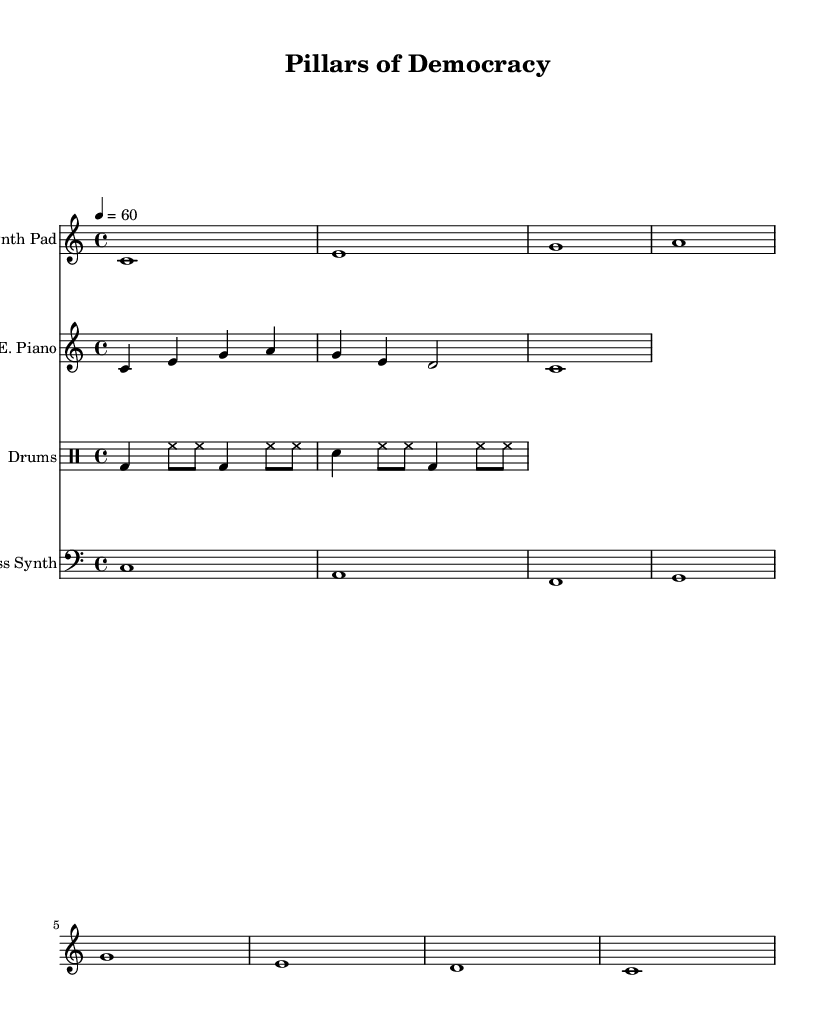What is the key signature of this music? The key signature is indicated at the beginning of the score and is C major, as there are no sharps or flats.
Answer: C major What is the time signature of the piece? The time signature is seen at the start of the score indicating the number of beats in each measure, which is 4/4.
Answer: 4/4 What is the tempo marking of this composition? The tempo marking is indicated in beats per minute, shown as 4 = 60, meaning there are 60 beats per minute.
Answer: 60 How many measures does the synth pad part contain? By examining the synth pad notation within the score, there are 8 distinct notes, which typically corresponds to 8 measures in this context.
Answer: 8 How many different instruments are featured in this score? The score displays four distinct staffs, indicating there are four unique instruments: Synth Pad, Electric Piano, Drums, and Bass Synth.
Answer: Four What type of rhythmic pattern is used in the drum part? The drum part outlines a basic rhythm structure focusing on kick (bd), snare (sn), and hi-hat (hh) patterns, which create a layered, electronic groove common in ambient music.
Answer: Electronic groove 